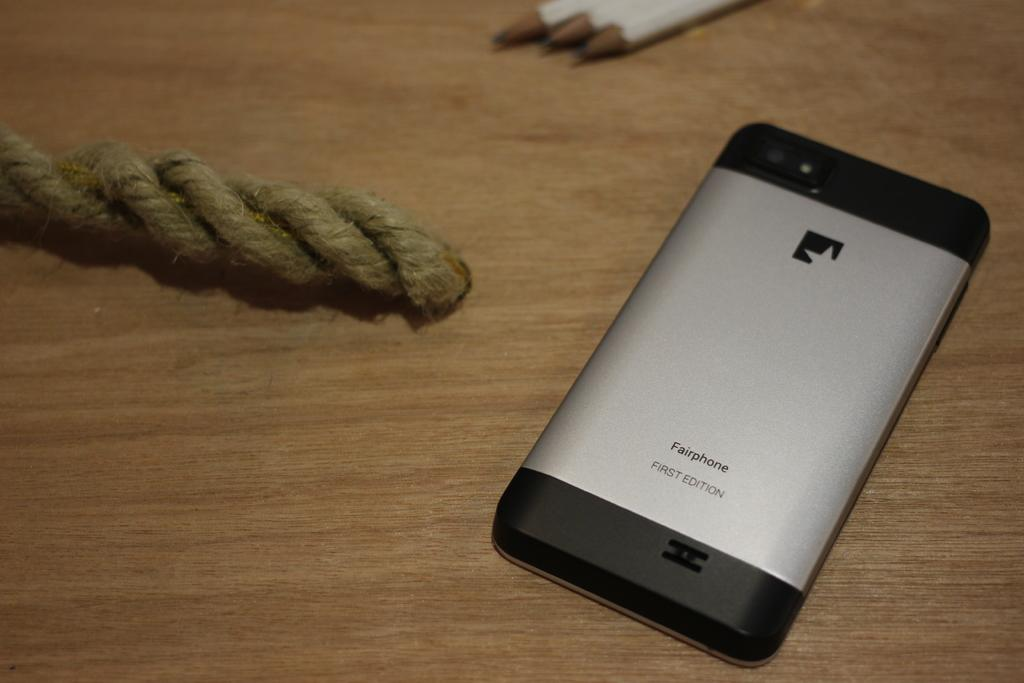<image>
Create a compact narrative representing the image presented. A first edition Fairphone is laying face down on a wooden surface. 